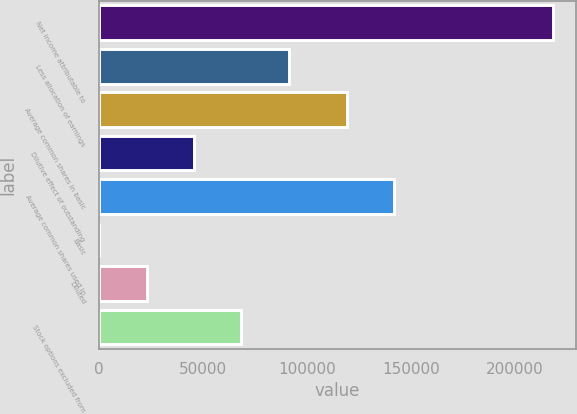Convert chart to OTSL. <chart><loc_0><loc_0><loc_500><loc_500><bar_chart><fcel>Net income attributable to<fcel>Less allocation of earnings<fcel>Average common shares in basic<fcel>Dilutive effect of outstanding<fcel>Average common shares used in<fcel>Basic<fcel>Diluted<fcel>Stock options excluded from<nl><fcel>218676<fcel>91314.3<fcel>119335<fcel>45658.1<fcel>142163<fcel>1.83<fcel>22830<fcel>68486.2<nl></chart> 